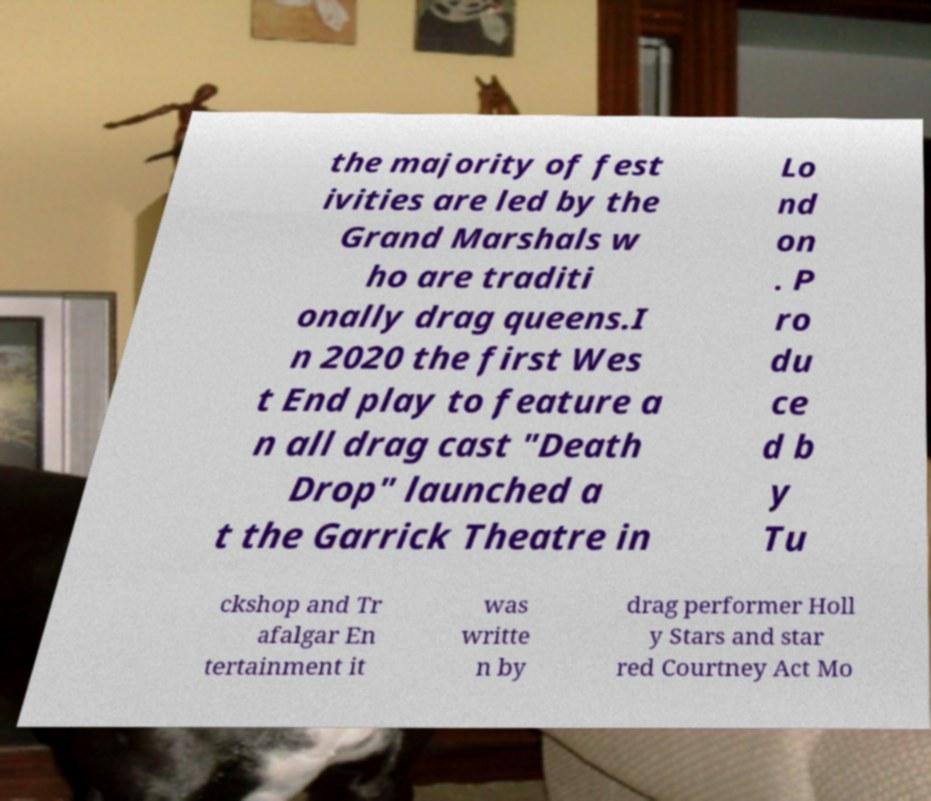Please identify and transcribe the text found in this image. the majority of fest ivities are led by the Grand Marshals w ho are traditi onally drag queens.I n 2020 the first Wes t End play to feature a n all drag cast "Death Drop" launched a t the Garrick Theatre in Lo nd on . P ro du ce d b y Tu ckshop and Tr afalgar En tertainment it was writte n by drag performer Holl y Stars and star red Courtney Act Mo 